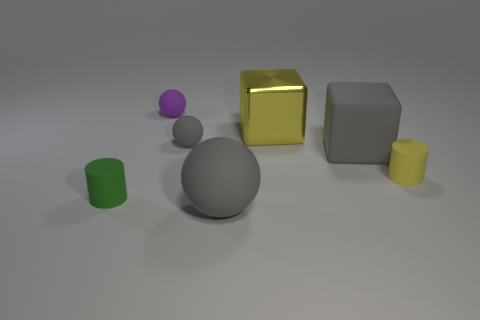Subtract all small purple matte balls. How many balls are left? 2 Add 2 tiny purple objects. How many objects exist? 9 Subtract all gray cubes. How many cubes are left? 1 Subtract 2 blocks. How many blocks are left? 0 Add 7 rubber balls. How many rubber balls exist? 10 Subtract 0 gray cylinders. How many objects are left? 7 Subtract all spheres. How many objects are left? 4 Subtract all purple spheres. Subtract all red cylinders. How many spheres are left? 2 Subtract all brown blocks. How many purple balls are left? 1 Subtract all yellow blocks. Subtract all matte cylinders. How many objects are left? 4 